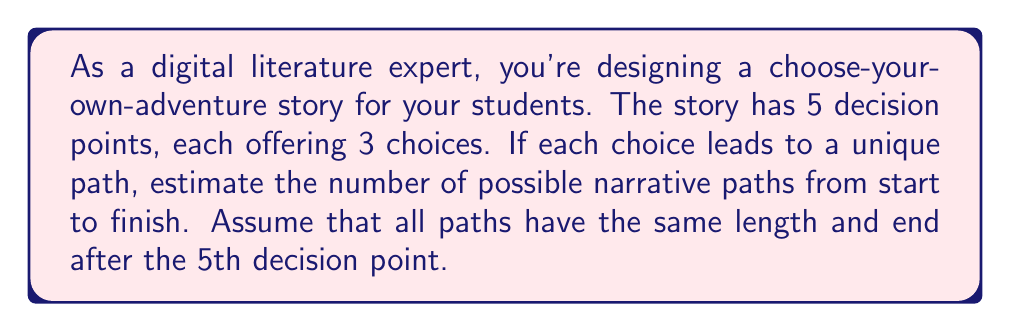Could you help me with this problem? To solve this problem, we need to understand the structure of the choose-your-own-adventure story:

1. There are 5 decision points.
2. At each decision point, there are 3 choices.
3. Each choice leads to a unique path.
4. All paths have the same length and end after the 5th decision point.

This scenario can be modeled as a tree structure, where each level represents a decision point, and each branch represents a choice.

The number of possible paths can be calculated using the multiplication principle:

$$ \text{Number of paths} = \text{Choices at 1st decision} \times \text{Choices at 2nd decision} \times ... \times \text{Choices at 5th decision} $$

Since there are 3 choices at each of the 5 decision points, we can express this as:

$$ \text{Number of paths} = 3 \times 3 \times 3 \times 3 \times 3 = 3^5 $$

To calculate $3^5$:

$$ 3^5 = 3 \times 3 \times 3 \times 3 \times 3 = 243 $$

Therefore, there are 243 possible narrative paths in this choose-your-own-adventure digital story.

This calculation demonstrates the exponential growth of possibilities in interactive narratives, showcasing the vast potential for diverse storytelling in digital literature.
Answer: 243 possible narrative paths 